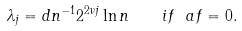<formula> <loc_0><loc_0><loc_500><loc_500>\lambda _ { j } = d n ^ { - 1 } 2 ^ { 2 \nu j } \ln n \quad i f \ a f = 0 .</formula> 